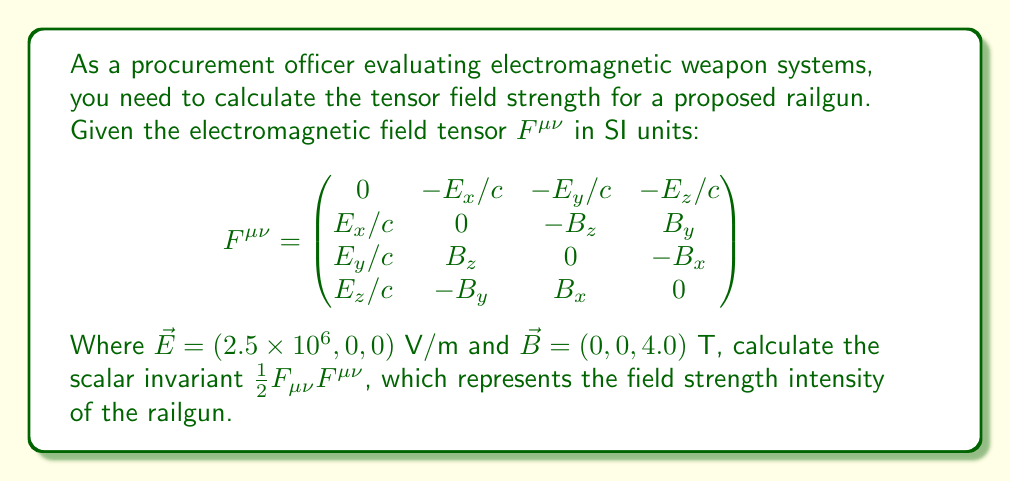Teach me how to tackle this problem. To calculate the scalar invariant $\frac{1}{2}F_{\mu\nu}F^{\mu\nu}$, we need to follow these steps:

1) First, we need to determine $F_{\mu\nu}$. This is the covariant form of the tensor, which can be obtained by lowering the indices of $F^{\mu\nu}$ using the metric tensor $g_{\mu\nu} = \text{diag}(1, -1, -1, -1)$:

   $$F_{\mu\nu} = \begin{pmatrix}
   0 & E_x/c & E_y/c & E_z/c \\
   -E_x/c & 0 & -B_z & B_y \\
   -E_y/c & B_z & 0 & -B_x \\
   -E_z/c & -B_y & B_x & 0
   \end{pmatrix}$$

2) Now, we need to multiply $F_{\mu\nu}$ and $F^{\mu\nu}$ and sum over all components:

   $$F_{\mu\nu}F^{\mu\nu} = 2[(E_x/c)^2 + (E_y/c)^2 + (E_z/c)^2 - B_x^2 - B_y^2 - B_z^2]$$

3) Substituting the given values:
   $E_x = 2.5 \times 10^6$ V/m, $E_y = E_z = 0$ V/m
   $B_x = B_y = 0$ T, $B_z = 4.0$ T

   $$F_{\mu\nu}F^{\mu\nu} = 2[(\frac{2.5 \times 10^6}{3 \times 10^8})^2 - 4.0^2]$$

4) Simplifying:
   $$F_{\mu\nu}F^{\mu\nu} = 2[(\frac{25}{9} \times 10^{-4}) - 16] \approx -31.9994$$

5) Finally, we multiply by $\frac{1}{2}$ to get the scalar invariant:

   $$\frac{1}{2}F_{\mu\nu}F^{\mu\nu} \approx -15.9997$$

This value represents the field strength intensity of the railgun, with the negative sign indicating that the magnetic field dominates over the electric field in this system.
Answer: $-15.9997$ 